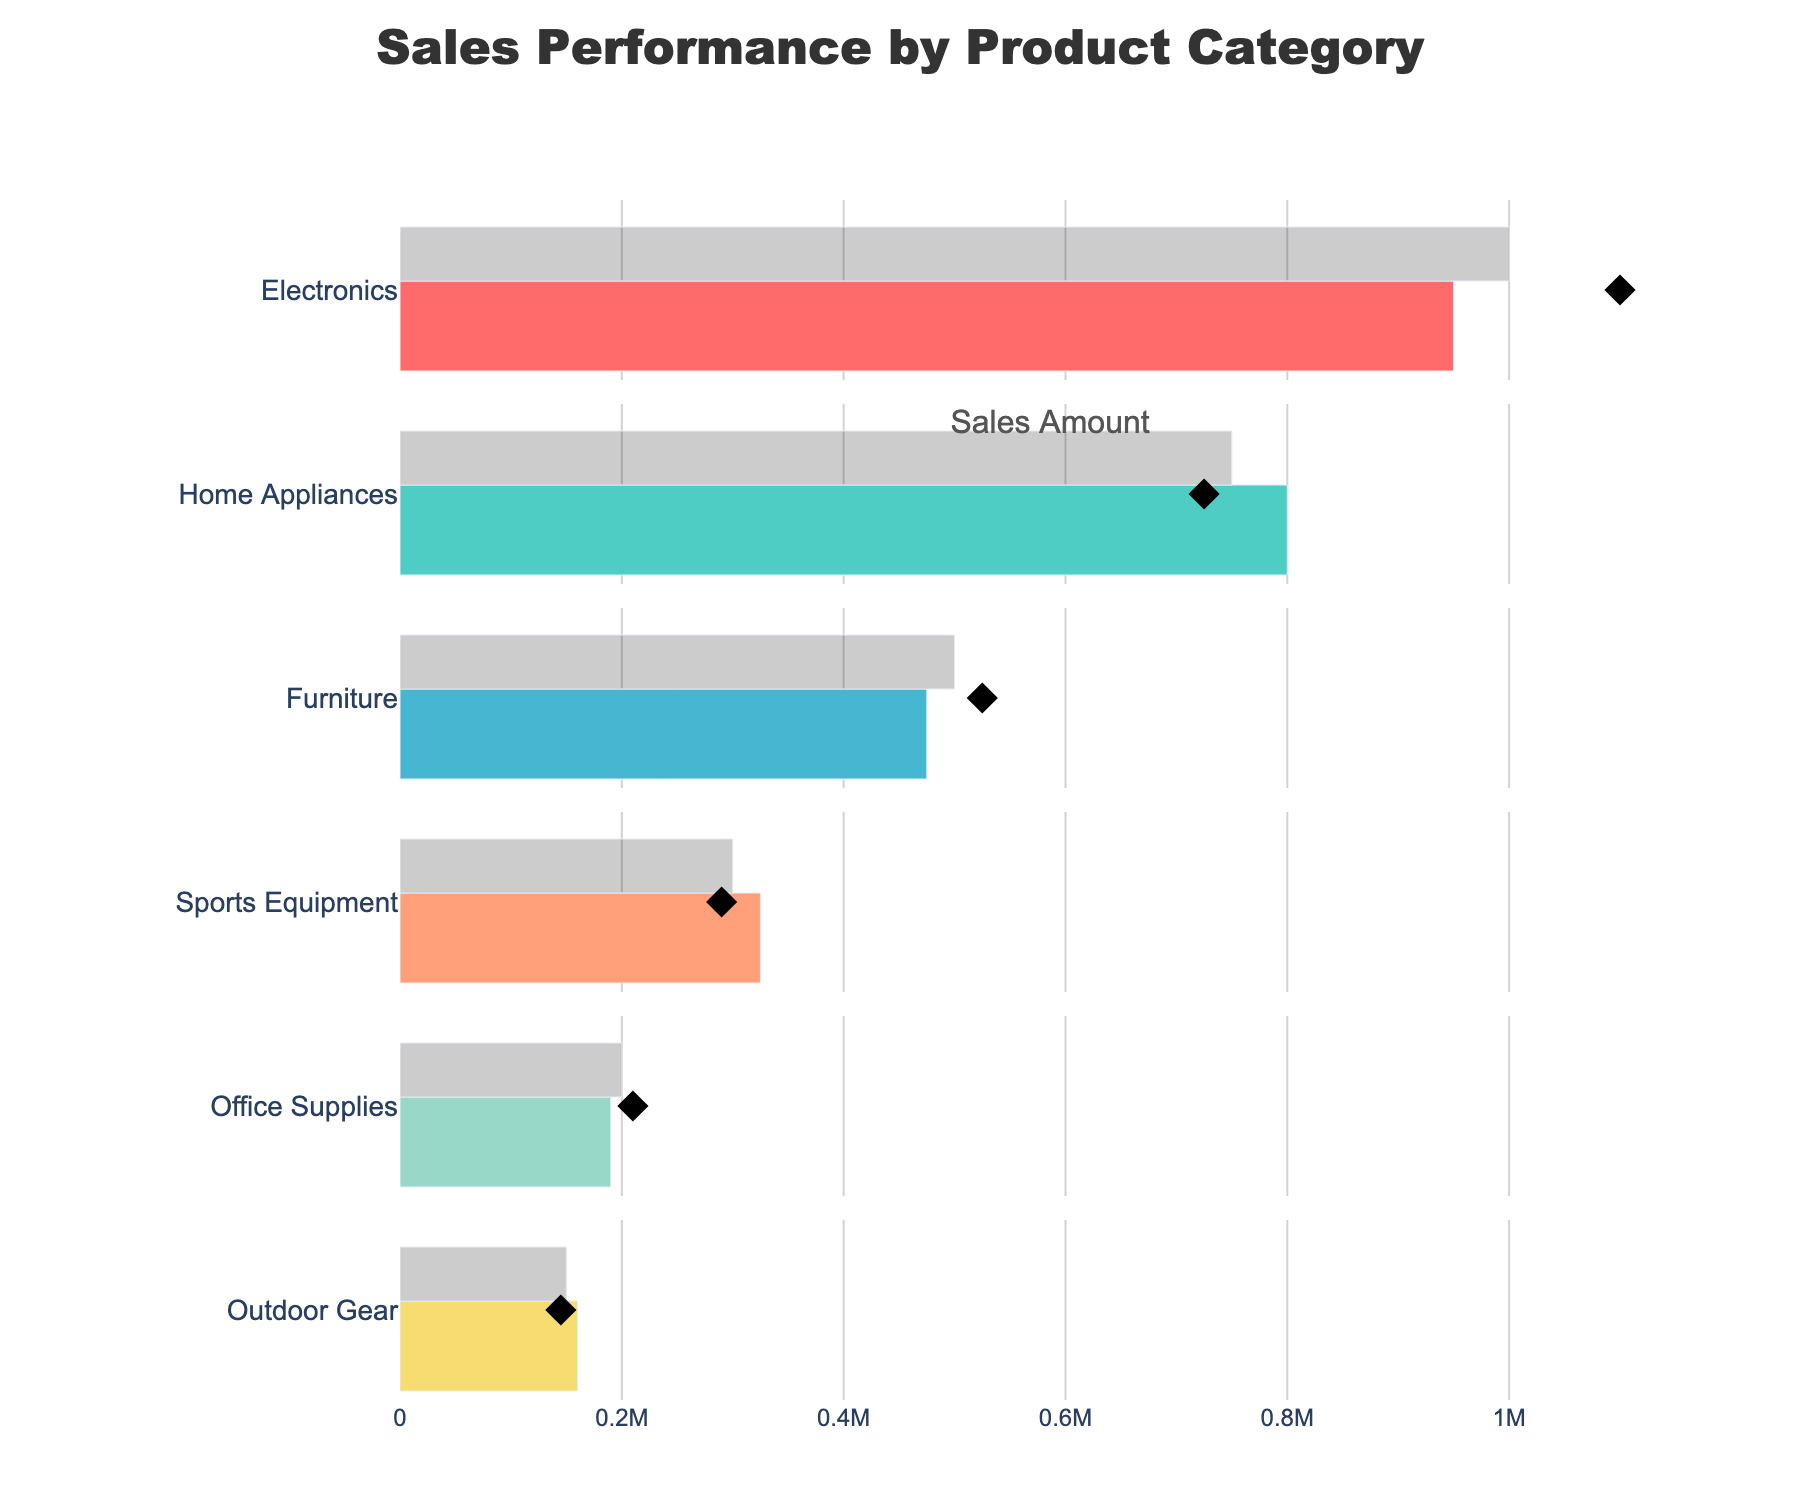What is the title of the chart? The title is printed at the center top of the figure in a larger, bold font. It clearly states what the chart is about.
Answer: Sales Performance by Product Category Which category has the highest actual sales? By looking at the horizontal bars representing actual sales, you can easily compare their lengths. The longest bar corresponds to the highest actual sales.
Answer: Home Appliances Is Benchmark for "Furniture" above or below the Target? Observe the diamond marker (Benchmark) in relation to the gray bar (Target) for the Furniture category. It shows the Benchmark is slightly below the Target.
Answer: Below Which categories' Actual sales are below their Benchmark? Look at where the colored bars (Actual) end in relation to the diamond markers (Benchmark). If the bar ends before the marker, they are below their Benchmark.
Answer: Electronics, Furniture, and Office Supplies Which category's Actual sales are very close to their Benchmark? Look for a category where the end of the colored bar (Actual) is nearly aligned with the diamond marker (Benchmark).
Answer: Electronics Which category has the smallest difference between Actual and Target sales? Compare the differences visually between the colored bars (Actual) and the gray bars (Target) for all categories. The smallest difference appears to be for Electronics.
Answer: Electronics 